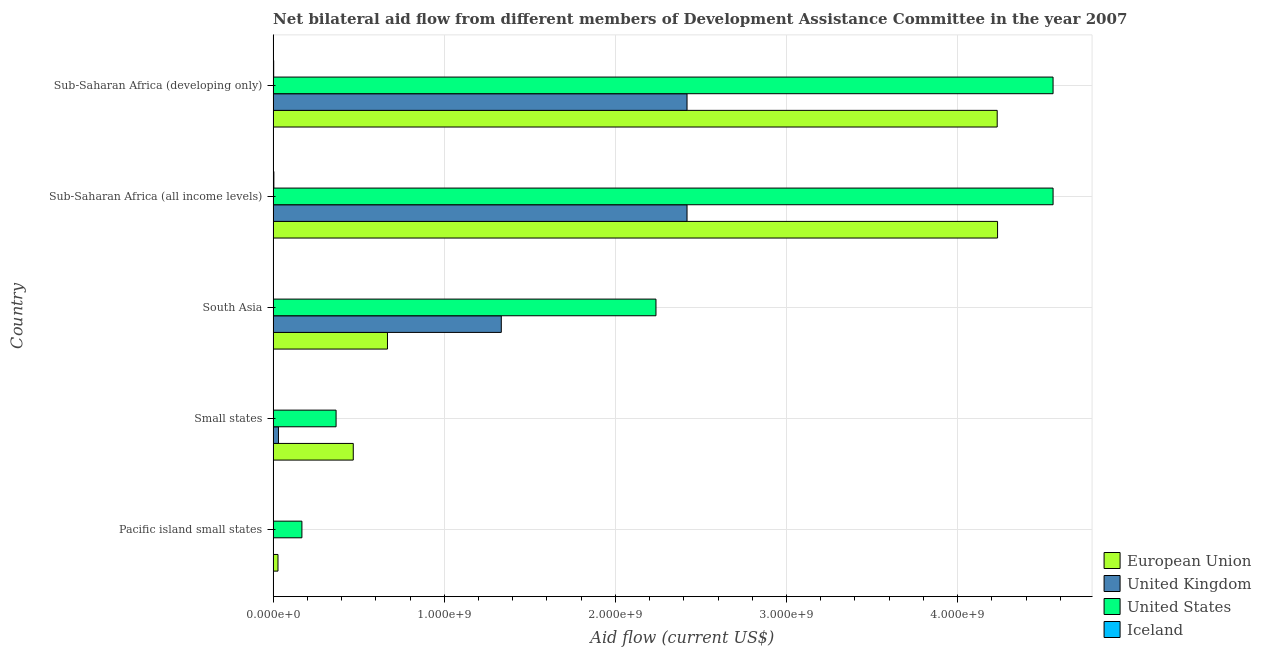How many different coloured bars are there?
Offer a very short reply. 4. How many groups of bars are there?
Make the answer very short. 5. Are the number of bars on each tick of the Y-axis equal?
Your answer should be compact. Yes. How many bars are there on the 2nd tick from the top?
Make the answer very short. 4. What is the label of the 5th group of bars from the top?
Make the answer very short. Pacific island small states. What is the amount of aid given by eu in Sub-Saharan Africa (developing only)?
Provide a short and direct response. 4.23e+09. Across all countries, what is the maximum amount of aid given by us?
Provide a short and direct response. 4.56e+09. Across all countries, what is the minimum amount of aid given by eu?
Offer a terse response. 2.84e+07. In which country was the amount of aid given by us maximum?
Offer a very short reply. Sub-Saharan Africa (all income levels). In which country was the amount of aid given by eu minimum?
Ensure brevity in your answer.  Pacific island small states. What is the total amount of aid given by us in the graph?
Provide a short and direct response. 1.19e+1. What is the difference between the amount of aid given by eu in Sub-Saharan Africa (all income levels) and that in Sub-Saharan Africa (developing only)?
Give a very brief answer. 2.07e+06. What is the difference between the amount of aid given by eu in Small states and the amount of aid given by uk in Sub-Saharan Africa (developing only)?
Make the answer very short. -1.95e+09. What is the average amount of aid given by us per country?
Give a very brief answer. 2.38e+09. What is the difference between the amount of aid given by us and amount of aid given by eu in South Asia?
Offer a terse response. 1.57e+09. In how many countries, is the amount of aid given by uk greater than 3600000000 US$?
Provide a succinct answer. 0. What is the ratio of the amount of aid given by uk in Small states to that in South Asia?
Your answer should be very brief. 0.02. Is the amount of aid given by us in Pacific island small states less than that in Sub-Saharan Africa (all income levels)?
Ensure brevity in your answer.  Yes. What is the difference between the highest and the second highest amount of aid given by eu?
Your response must be concise. 2.07e+06. What is the difference between the highest and the lowest amount of aid given by eu?
Ensure brevity in your answer.  4.20e+09. In how many countries, is the amount of aid given by iceland greater than the average amount of aid given by iceland taken over all countries?
Offer a very short reply. 2. Is the sum of the amount of aid given by eu in South Asia and Sub-Saharan Africa (all income levels) greater than the maximum amount of aid given by uk across all countries?
Provide a succinct answer. Yes. Is it the case that in every country, the sum of the amount of aid given by eu and amount of aid given by us is greater than the sum of amount of aid given by uk and amount of aid given by iceland?
Provide a succinct answer. Yes. What does the 3rd bar from the bottom in Pacific island small states represents?
Your answer should be compact. United States. What is the difference between two consecutive major ticks on the X-axis?
Your answer should be very brief. 1.00e+09. Are the values on the major ticks of X-axis written in scientific E-notation?
Give a very brief answer. Yes. Does the graph contain any zero values?
Offer a terse response. No. Where does the legend appear in the graph?
Provide a succinct answer. Bottom right. How many legend labels are there?
Keep it short and to the point. 4. What is the title of the graph?
Offer a very short reply. Net bilateral aid flow from different members of Development Assistance Committee in the year 2007. What is the label or title of the Y-axis?
Your response must be concise. Country. What is the Aid flow (current US$) in European Union in Pacific island small states?
Ensure brevity in your answer.  2.84e+07. What is the Aid flow (current US$) of United Kingdom in Pacific island small states?
Provide a succinct answer. 1.02e+06. What is the Aid flow (current US$) of United States in Pacific island small states?
Ensure brevity in your answer.  1.68e+08. What is the Aid flow (current US$) in Iceland in Pacific island small states?
Your response must be concise. 2.90e+05. What is the Aid flow (current US$) of European Union in Small states?
Your response must be concise. 4.68e+08. What is the Aid flow (current US$) in United Kingdom in Small states?
Ensure brevity in your answer.  3.12e+07. What is the Aid flow (current US$) in United States in Small states?
Provide a succinct answer. 3.68e+08. What is the Aid flow (current US$) in Iceland in Small states?
Offer a terse response. 1.00e+05. What is the Aid flow (current US$) in European Union in South Asia?
Provide a short and direct response. 6.68e+08. What is the Aid flow (current US$) of United Kingdom in South Asia?
Your answer should be very brief. 1.33e+09. What is the Aid flow (current US$) in United States in South Asia?
Keep it short and to the point. 2.24e+09. What is the Aid flow (current US$) of European Union in Sub-Saharan Africa (all income levels)?
Your answer should be very brief. 4.23e+09. What is the Aid flow (current US$) in United Kingdom in Sub-Saharan Africa (all income levels)?
Make the answer very short. 2.42e+09. What is the Aid flow (current US$) in United States in Sub-Saharan Africa (all income levels)?
Your answer should be compact. 4.56e+09. What is the Aid flow (current US$) of Iceland in Sub-Saharan Africa (all income levels)?
Ensure brevity in your answer.  4.37e+06. What is the Aid flow (current US$) of European Union in Sub-Saharan Africa (developing only)?
Your response must be concise. 4.23e+09. What is the Aid flow (current US$) of United Kingdom in Sub-Saharan Africa (developing only)?
Ensure brevity in your answer.  2.42e+09. What is the Aid flow (current US$) in United States in Sub-Saharan Africa (developing only)?
Provide a succinct answer. 4.56e+09. What is the Aid flow (current US$) in Iceland in Sub-Saharan Africa (developing only)?
Make the answer very short. 3.33e+06. Across all countries, what is the maximum Aid flow (current US$) in European Union?
Give a very brief answer. 4.23e+09. Across all countries, what is the maximum Aid flow (current US$) in United Kingdom?
Give a very brief answer. 2.42e+09. Across all countries, what is the maximum Aid flow (current US$) in United States?
Your answer should be compact. 4.56e+09. Across all countries, what is the maximum Aid flow (current US$) of Iceland?
Your answer should be compact. 4.37e+06. Across all countries, what is the minimum Aid flow (current US$) in European Union?
Offer a terse response. 2.84e+07. Across all countries, what is the minimum Aid flow (current US$) in United Kingdom?
Offer a terse response. 1.02e+06. Across all countries, what is the minimum Aid flow (current US$) of United States?
Your answer should be compact. 1.68e+08. What is the total Aid flow (current US$) of European Union in the graph?
Ensure brevity in your answer.  9.63e+09. What is the total Aid flow (current US$) of United Kingdom in the graph?
Your response must be concise. 6.20e+09. What is the total Aid flow (current US$) of United States in the graph?
Your answer should be compact. 1.19e+1. What is the total Aid flow (current US$) in Iceland in the graph?
Keep it short and to the point. 8.31e+06. What is the difference between the Aid flow (current US$) in European Union in Pacific island small states and that in Small states?
Ensure brevity in your answer.  -4.40e+08. What is the difference between the Aid flow (current US$) of United Kingdom in Pacific island small states and that in Small states?
Your response must be concise. -3.02e+07. What is the difference between the Aid flow (current US$) of United States in Pacific island small states and that in Small states?
Offer a very short reply. -2.00e+08. What is the difference between the Aid flow (current US$) of European Union in Pacific island small states and that in South Asia?
Offer a terse response. -6.40e+08. What is the difference between the Aid flow (current US$) in United Kingdom in Pacific island small states and that in South Asia?
Your answer should be very brief. -1.33e+09. What is the difference between the Aid flow (current US$) of United States in Pacific island small states and that in South Asia?
Ensure brevity in your answer.  -2.07e+09. What is the difference between the Aid flow (current US$) of European Union in Pacific island small states and that in Sub-Saharan Africa (all income levels)?
Offer a terse response. -4.20e+09. What is the difference between the Aid flow (current US$) in United Kingdom in Pacific island small states and that in Sub-Saharan Africa (all income levels)?
Make the answer very short. -2.42e+09. What is the difference between the Aid flow (current US$) of United States in Pacific island small states and that in Sub-Saharan Africa (all income levels)?
Ensure brevity in your answer.  -4.39e+09. What is the difference between the Aid flow (current US$) in Iceland in Pacific island small states and that in Sub-Saharan Africa (all income levels)?
Keep it short and to the point. -4.08e+06. What is the difference between the Aid flow (current US$) of European Union in Pacific island small states and that in Sub-Saharan Africa (developing only)?
Your answer should be very brief. -4.20e+09. What is the difference between the Aid flow (current US$) of United Kingdom in Pacific island small states and that in Sub-Saharan Africa (developing only)?
Offer a very short reply. -2.42e+09. What is the difference between the Aid flow (current US$) of United States in Pacific island small states and that in Sub-Saharan Africa (developing only)?
Ensure brevity in your answer.  -4.39e+09. What is the difference between the Aid flow (current US$) in Iceland in Pacific island small states and that in Sub-Saharan Africa (developing only)?
Your answer should be very brief. -3.04e+06. What is the difference between the Aid flow (current US$) of European Union in Small states and that in South Asia?
Offer a terse response. -2.00e+08. What is the difference between the Aid flow (current US$) in United Kingdom in Small states and that in South Asia?
Your answer should be very brief. -1.30e+09. What is the difference between the Aid flow (current US$) of United States in Small states and that in South Asia?
Offer a terse response. -1.87e+09. What is the difference between the Aid flow (current US$) of Iceland in Small states and that in South Asia?
Offer a terse response. -1.20e+05. What is the difference between the Aid flow (current US$) of European Union in Small states and that in Sub-Saharan Africa (all income levels)?
Your response must be concise. -3.76e+09. What is the difference between the Aid flow (current US$) in United Kingdom in Small states and that in Sub-Saharan Africa (all income levels)?
Keep it short and to the point. -2.39e+09. What is the difference between the Aid flow (current US$) of United States in Small states and that in Sub-Saharan Africa (all income levels)?
Provide a short and direct response. -4.19e+09. What is the difference between the Aid flow (current US$) in Iceland in Small states and that in Sub-Saharan Africa (all income levels)?
Offer a very short reply. -4.27e+06. What is the difference between the Aid flow (current US$) in European Union in Small states and that in Sub-Saharan Africa (developing only)?
Your answer should be very brief. -3.76e+09. What is the difference between the Aid flow (current US$) of United Kingdom in Small states and that in Sub-Saharan Africa (developing only)?
Offer a very short reply. -2.39e+09. What is the difference between the Aid flow (current US$) in United States in Small states and that in Sub-Saharan Africa (developing only)?
Keep it short and to the point. -4.19e+09. What is the difference between the Aid flow (current US$) of Iceland in Small states and that in Sub-Saharan Africa (developing only)?
Provide a short and direct response. -3.23e+06. What is the difference between the Aid flow (current US$) in European Union in South Asia and that in Sub-Saharan Africa (all income levels)?
Give a very brief answer. -3.57e+09. What is the difference between the Aid flow (current US$) in United Kingdom in South Asia and that in Sub-Saharan Africa (all income levels)?
Provide a succinct answer. -1.09e+09. What is the difference between the Aid flow (current US$) of United States in South Asia and that in Sub-Saharan Africa (all income levels)?
Make the answer very short. -2.32e+09. What is the difference between the Aid flow (current US$) in Iceland in South Asia and that in Sub-Saharan Africa (all income levels)?
Keep it short and to the point. -4.15e+06. What is the difference between the Aid flow (current US$) of European Union in South Asia and that in Sub-Saharan Africa (developing only)?
Give a very brief answer. -3.56e+09. What is the difference between the Aid flow (current US$) of United Kingdom in South Asia and that in Sub-Saharan Africa (developing only)?
Provide a short and direct response. -1.09e+09. What is the difference between the Aid flow (current US$) of United States in South Asia and that in Sub-Saharan Africa (developing only)?
Your response must be concise. -2.32e+09. What is the difference between the Aid flow (current US$) in Iceland in South Asia and that in Sub-Saharan Africa (developing only)?
Provide a succinct answer. -3.11e+06. What is the difference between the Aid flow (current US$) in European Union in Sub-Saharan Africa (all income levels) and that in Sub-Saharan Africa (developing only)?
Provide a succinct answer. 2.07e+06. What is the difference between the Aid flow (current US$) in Iceland in Sub-Saharan Africa (all income levels) and that in Sub-Saharan Africa (developing only)?
Provide a short and direct response. 1.04e+06. What is the difference between the Aid flow (current US$) in European Union in Pacific island small states and the Aid flow (current US$) in United Kingdom in Small states?
Offer a very short reply. -2.85e+06. What is the difference between the Aid flow (current US$) of European Union in Pacific island small states and the Aid flow (current US$) of United States in Small states?
Ensure brevity in your answer.  -3.40e+08. What is the difference between the Aid flow (current US$) in European Union in Pacific island small states and the Aid flow (current US$) in Iceland in Small states?
Your response must be concise. 2.83e+07. What is the difference between the Aid flow (current US$) of United Kingdom in Pacific island small states and the Aid flow (current US$) of United States in Small states?
Provide a succinct answer. -3.67e+08. What is the difference between the Aid flow (current US$) of United Kingdom in Pacific island small states and the Aid flow (current US$) of Iceland in Small states?
Your answer should be very brief. 9.20e+05. What is the difference between the Aid flow (current US$) of United States in Pacific island small states and the Aid flow (current US$) of Iceland in Small states?
Give a very brief answer. 1.68e+08. What is the difference between the Aid flow (current US$) of European Union in Pacific island small states and the Aid flow (current US$) of United Kingdom in South Asia?
Provide a short and direct response. -1.30e+09. What is the difference between the Aid flow (current US$) in European Union in Pacific island small states and the Aid flow (current US$) in United States in South Asia?
Give a very brief answer. -2.21e+09. What is the difference between the Aid flow (current US$) of European Union in Pacific island small states and the Aid flow (current US$) of Iceland in South Asia?
Your response must be concise. 2.82e+07. What is the difference between the Aid flow (current US$) in United Kingdom in Pacific island small states and the Aid flow (current US$) in United States in South Asia?
Offer a terse response. -2.24e+09. What is the difference between the Aid flow (current US$) of United Kingdom in Pacific island small states and the Aid flow (current US$) of Iceland in South Asia?
Keep it short and to the point. 8.00e+05. What is the difference between the Aid flow (current US$) of United States in Pacific island small states and the Aid flow (current US$) of Iceland in South Asia?
Your response must be concise. 1.68e+08. What is the difference between the Aid flow (current US$) in European Union in Pacific island small states and the Aid flow (current US$) in United Kingdom in Sub-Saharan Africa (all income levels)?
Keep it short and to the point. -2.39e+09. What is the difference between the Aid flow (current US$) of European Union in Pacific island small states and the Aid flow (current US$) of United States in Sub-Saharan Africa (all income levels)?
Provide a short and direct response. -4.53e+09. What is the difference between the Aid flow (current US$) in European Union in Pacific island small states and the Aid flow (current US$) in Iceland in Sub-Saharan Africa (all income levels)?
Ensure brevity in your answer.  2.40e+07. What is the difference between the Aid flow (current US$) of United Kingdom in Pacific island small states and the Aid flow (current US$) of United States in Sub-Saharan Africa (all income levels)?
Offer a terse response. -4.56e+09. What is the difference between the Aid flow (current US$) of United Kingdom in Pacific island small states and the Aid flow (current US$) of Iceland in Sub-Saharan Africa (all income levels)?
Give a very brief answer. -3.35e+06. What is the difference between the Aid flow (current US$) of United States in Pacific island small states and the Aid flow (current US$) of Iceland in Sub-Saharan Africa (all income levels)?
Keep it short and to the point. 1.64e+08. What is the difference between the Aid flow (current US$) of European Union in Pacific island small states and the Aid flow (current US$) of United Kingdom in Sub-Saharan Africa (developing only)?
Offer a terse response. -2.39e+09. What is the difference between the Aid flow (current US$) of European Union in Pacific island small states and the Aid flow (current US$) of United States in Sub-Saharan Africa (developing only)?
Make the answer very short. -4.53e+09. What is the difference between the Aid flow (current US$) in European Union in Pacific island small states and the Aid flow (current US$) in Iceland in Sub-Saharan Africa (developing only)?
Your answer should be very brief. 2.51e+07. What is the difference between the Aid flow (current US$) of United Kingdom in Pacific island small states and the Aid flow (current US$) of United States in Sub-Saharan Africa (developing only)?
Make the answer very short. -4.56e+09. What is the difference between the Aid flow (current US$) of United Kingdom in Pacific island small states and the Aid flow (current US$) of Iceland in Sub-Saharan Africa (developing only)?
Give a very brief answer. -2.31e+06. What is the difference between the Aid flow (current US$) in United States in Pacific island small states and the Aid flow (current US$) in Iceland in Sub-Saharan Africa (developing only)?
Your response must be concise. 1.65e+08. What is the difference between the Aid flow (current US$) of European Union in Small states and the Aid flow (current US$) of United Kingdom in South Asia?
Provide a short and direct response. -8.65e+08. What is the difference between the Aid flow (current US$) in European Union in Small states and the Aid flow (current US$) in United States in South Asia?
Make the answer very short. -1.77e+09. What is the difference between the Aid flow (current US$) of European Union in Small states and the Aid flow (current US$) of Iceland in South Asia?
Your response must be concise. 4.68e+08. What is the difference between the Aid flow (current US$) of United Kingdom in Small states and the Aid flow (current US$) of United States in South Asia?
Ensure brevity in your answer.  -2.21e+09. What is the difference between the Aid flow (current US$) in United Kingdom in Small states and the Aid flow (current US$) in Iceland in South Asia?
Make the answer very short. 3.10e+07. What is the difference between the Aid flow (current US$) of United States in Small states and the Aid flow (current US$) of Iceland in South Asia?
Your response must be concise. 3.68e+08. What is the difference between the Aid flow (current US$) in European Union in Small states and the Aid flow (current US$) in United Kingdom in Sub-Saharan Africa (all income levels)?
Make the answer very short. -1.95e+09. What is the difference between the Aid flow (current US$) of European Union in Small states and the Aid flow (current US$) of United States in Sub-Saharan Africa (all income levels)?
Your answer should be compact. -4.09e+09. What is the difference between the Aid flow (current US$) of European Union in Small states and the Aid flow (current US$) of Iceland in Sub-Saharan Africa (all income levels)?
Provide a short and direct response. 4.64e+08. What is the difference between the Aid flow (current US$) in United Kingdom in Small states and the Aid flow (current US$) in United States in Sub-Saharan Africa (all income levels)?
Offer a very short reply. -4.53e+09. What is the difference between the Aid flow (current US$) in United Kingdom in Small states and the Aid flow (current US$) in Iceland in Sub-Saharan Africa (all income levels)?
Ensure brevity in your answer.  2.69e+07. What is the difference between the Aid flow (current US$) in United States in Small states and the Aid flow (current US$) in Iceland in Sub-Saharan Africa (all income levels)?
Your response must be concise. 3.64e+08. What is the difference between the Aid flow (current US$) in European Union in Small states and the Aid flow (current US$) in United Kingdom in Sub-Saharan Africa (developing only)?
Your answer should be very brief. -1.95e+09. What is the difference between the Aid flow (current US$) of European Union in Small states and the Aid flow (current US$) of United States in Sub-Saharan Africa (developing only)?
Offer a very short reply. -4.09e+09. What is the difference between the Aid flow (current US$) of European Union in Small states and the Aid flow (current US$) of Iceland in Sub-Saharan Africa (developing only)?
Offer a terse response. 4.65e+08. What is the difference between the Aid flow (current US$) in United Kingdom in Small states and the Aid flow (current US$) in United States in Sub-Saharan Africa (developing only)?
Offer a terse response. -4.53e+09. What is the difference between the Aid flow (current US$) in United Kingdom in Small states and the Aid flow (current US$) in Iceland in Sub-Saharan Africa (developing only)?
Provide a short and direct response. 2.79e+07. What is the difference between the Aid flow (current US$) of United States in Small states and the Aid flow (current US$) of Iceland in Sub-Saharan Africa (developing only)?
Give a very brief answer. 3.65e+08. What is the difference between the Aid flow (current US$) in European Union in South Asia and the Aid flow (current US$) in United Kingdom in Sub-Saharan Africa (all income levels)?
Your response must be concise. -1.75e+09. What is the difference between the Aid flow (current US$) in European Union in South Asia and the Aid flow (current US$) in United States in Sub-Saharan Africa (all income levels)?
Keep it short and to the point. -3.89e+09. What is the difference between the Aid flow (current US$) in European Union in South Asia and the Aid flow (current US$) in Iceland in Sub-Saharan Africa (all income levels)?
Your answer should be very brief. 6.64e+08. What is the difference between the Aid flow (current US$) of United Kingdom in South Asia and the Aid flow (current US$) of United States in Sub-Saharan Africa (all income levels)?
Give a very brief answer. -3.22e+09. What is the difference between the Aid flow (current US$) in United Kingdom in South Asia and the Aid flow (current US$) in Iceland in Sub-Saharan Africa (all income levels)?
Provide a succinct answer. 1.33e+09. What is the difference between the Aid flow (current US$) of United States in South Asia and the Aid flow (current US$) of Iceland in Sub-Saharan Africa (all income levels)?
Keep it short and to the point. 2.23e+09. What is the difference between the Aid flow (current US$) in European Union in South Asia and the Aid flow (current US$) in United Kingdom in Sub-Saharan Africa (developing only)?
Make the answer very short. -1.75e+09. What is the difference between the Aid flow (current US$) of European Union in South Asia and the Aid flow (current US$) of United States in Sub-Saharan Africa (developing only)?
Make the answer very short. -3.89e+09. What is the difference between the Aid flow (current US$) of European Union in South Asia and the Aid flow (current US$) of Iceland in Sub-Saharan Africa (developing only)?
Provide a succinct answer. 6.65e+08. What is the difference between the Aid flow (current US$) in United Kingdom in South Asia and the Aid flow (current US$) in United States in Sub-Saharan Africa (developing only)?
Offer a terse response. -3.22e+09. What is the difference between the Aid flow (current US$) of United Kingdom in South Asia and the Aid flow (current US$) of Iceland in Sub-Saharan Africa (developing only)?
Your answer should be very brief. 1.33e+09. What is the difference between the Aid flow (current US$) of United States in South Asia and the Aid flow (current US$) of Iceland in Sub-Saharan Africa (developing only)?
Give a very brief answer. 2.23e+09. What is the difference between the Aid flow (current US$) of European Union in Sub-Saharan Africa (all income levels) and the Aid flow (current US$) of United Kingdom in Sub-Saharan Africa (developing only)?
Ensure brevity in your answer.  1.81e+09. What is the difference between the Aid flow (current US$) in European Union in Sub-Saharan Africa (all income levels) and the Aid flow (current US$) in United States in Sub-Saharan Africa (developing only)?
Keep it short and to the point. -3.24e+08. What is the difference between the Aid flow (current US$) in European Union in Sub-Saharan Africa (all income levels) and the Aid flow (current US$) in Iceland in Sub-Saharan Africa (developing only)?
Offer a terse response. 4.23e+09. What is the difference between the Aid flow (current US$) in United Kingdom in Sub-Saharan Africa (all income levels) and the Aid flow (current US$) in United States in Sub-Saharan Africa (developing only)?
Provide a succinct answer. -2.14e+09. What is the difference between the Aid flow (current US$) in United Kingdom in Sub-Saharan Africa (all income levels) and the Aid flow (current US$) in Iceland in Sub-Saharan Africa (developing only)?
Provide a succinct answer. 2.42e+09. What is the difference between the Aid flow (current US$) of United States in Sub-Saharan Africa (all income levels) and the Aid flow (current US$) of Iceland in Sub-Saharan Africa (developing only)?
Provide a short and direct response. 4.55e+09. What is the average Aid flow (current US$) in European Union per country?
Offer a terse response. 1.93e+09. What is the average Aid flow (current US$) in United Kingdom per country?
Give a very brief answer. 1.24e+09. What is the average Aid flow (current US$) in United States per country?
Provide a succinct answer. 2.38e+09. What is the average Aid flow (current US$) in Iceland per country?
Keep it short and to the point. 1.66e+06. What is the difference between the Aid flow (current US$) of European Union and Aid flow (current US$) of United Kingdom in Pacific island small states?
Provide a succinct answer. 2.74e+07. What is the difference between the Aid flow (current US$) in European Union and Aid flow (current US$) in United States in Pacific island small states?
Provide a short and direct response. -1.40e+08. What is the difference between the Aid flow (current US$) in European Union and Aid flow (current US$) in Iceland in Pacific island small states?
Keep it short and to the point. 2.81e+07. What is the difference between the Aid flow (current US$) of United Kingdom and Aid flow (current US$) of United States in Pacific island small states?
Offer a terse response. -1.67e+08. What is the difference between the Aid flow (current US$) of United Kingdom and Aid flow (current US$) of Iceland in Pacific island small states?
Give a very brief answer. 7.30e+05. What is the difference between the Aid flow (current US$) in United States and Aid flow (current US$) in Iceland in Pacific island small states?
Your answer should be very brief. 1.68e+08. What is the difference between the Aid flow (current US$) in European Union and Aid flow (current US$) in United Kingdom in Small states?
Ensure brevity in your answer.  4.37e+08. What is the difference between the Aid flow (current US$) of European Union and Aid flow (current US$) of United States in Small states?
Offer a terse response. 1.00e+08. What is the difference between the Aid flow (current US$) in European Union and Aid flow (current US$) in Iceland in Small states?
Your answer should be compact. 4.68e+08. What is the difference between the Aid flow (current US$) of United Kingdom and Aid flow (current US$) of United States in Small states?
Offer a very short reply. -3.37e+08. What is the difference between the Aid flow (current US$) of United Kingdom and Aid flow (current US$) of Iceland in Small states?
Give a very brief answer. 3.12e+07. What is the difference between the Aid flow (current US$) of United States and Aid flow (current US$) of Iceland in Small states?
Offer a very short reply. 3.68e+08. What is the difference between the Aid flow (current US$) of European Union and Aid flow (current US$) of United Kingdom in South Asia?
Offer a very short reply. -6.65e+08. What is the difference between the Aid flow (current US$) of European Union and Aid flow (current US$) of United States in South Asia?
Ensure brevity in your answer.  -1.57e+09. What is the difference between the Aid flow (current US$) in European Union and Aid flow (current US$) in Iceland in South Asia?
Provide a succinct answer. 6.68e+08. What is the difference between the Aid flow (current US$) of United Kingdom and Aid flow (current US$) of United States in South Asia?
Keep it short and to the point. -9.04e+08. What is the difference between the Aid flow (current US$) of United Kingdom and Aid flow (current US$) of Iceland in South Asia?
Provide a short and direct response. 1.33e+09. What is the difference between the Aid flow (current US$) of United States and Aid flow (current US$) of Iceland in South Asia?
Your response must be concise. 2.24e+09. What is the difference between the Aid flow (current US$) of European Union and Aid flow (current US$) of United Kingdom in Sub-Saharan Africa (all income levels)?
Make the answer very short. 1.81e+09. What is the difference between the Aid flow (current US$) of European Union and Aid flow (current US$) of United States in Sub-Saharan Africa (all income levels)?
Provide a short and direct response. -3.24e+08. What is the difference between the Aid flow (current US$) of European Union and Aid flow (current US$) of Iceland in Sub-Saharan Africa (all income levels)?
Your answer should be very brief. 4.23e+09. What is the difference between the Aid flow (current US$) in United Kingdom and Aid flow (current US$) in United States in Sub-Saharan Africa (all income levels)?
Ensure brevity in your answer.  -2.14e+09. What is the difference between the Aid flow (current US$) of United Kingdom and Aid flow (current US$) of Iceland in Sub-Saharan Africa (all income levels)?
Provide a short and direct response. 2.41e+09. What is the difference between the Aid flow (current US$) in United States and Aid flow (current US$) in Iceland in Sub-Saharan Africa (all income levels)?
Offer a terse response. 4.55e+09. What is the difference between the Aid flow (current US$) of European Union and Aid flow (current US$) of United Kingdom in Sub-Saharan Africa (developing only)?
Make the answer very short. 1.81e+09. What is the difference between the Aid flow (current US$) in European Union and Aid flow (current US$) in United States in Sub-Saharan Africa (developing only)?
Ensure brevity in your answer.  -3.26e+08. What is the difference between the Aid flow (current US$) of European Union and Aid flow (current US$) of Iceland in Sub-Saharan Africa (developing only)?
Ensure brevity in your answer.  4.23e+09. What is the difference between the Aid flow (current US$) of United Kingdom and Aid flow (current US$) of United States in Sub-Saharan Africa (developing only)?
Your response must be concise. -2.14e+09. What is the difference between the Aid flow (current US$) of United Kingdom and Aid flow (current US$) of Iceland in Sub-Saharan Africa (developing only)?
Keep it short and to the point. 2.42e+09. What is the difference between the Aid flow (current US$) in United States and Aid flow (current US$) in Iceland in Sub-Saharan Africa (developing only)?
Keep it short and to the point. 4.55e+09. What is the ratio of the Aid flow (current US$) of European Union in Pacific island small states to that in Small states?
Give a very brief answer. 0.06. What is the ratio of the Aid flow (current US$) of United Kingdom in Pacific island small states to that in Small states?
Ensure brevity in your answer.  0.03. What is the ratio of the Aid flow (current US$) of United States in Pacific island small states to that in Small states?
Your answer should be compact. 0.46. What is the ratio of the Aid flow (current US$) in European Union in Pacific island small states to that in South Asia?
Make the answer very short. 0.04. What is the ratio of the Aid flow (current US$) in United Kingdom in Pacific island small states to that in South Asia?
Your response must be concise. 0. What is the ratio of the Aid flow (current US$) in United States in Pacific island small states to that in South Asia?
Your response must be concise. 0.08. What is the ratio of the Aid flow (current US$) of Iceland in Pacific island small states to that in South Asia?
Provide a succinct answer. 1.32. What is the ratio of the Aid flow (current US$) of European Union in Pacific island small states to that in Sub-Saharan Africa (all income levels)?
Your answer should be compact. 0.01. What is the ratio of the Aid flow (current US$) of United States in Pacific island small states to that in Sub-Saharan Africa (all income levels)?
Make the answer very short. 0.04. What is the ratio of the Aid flow (current US$) of Iceland in Pacific island small states to that in Sub-Saharan Africa (all income levels)?
Ensure brevity in your answer.  0.07. What is the ratio of the Aid flow (current US$) in European Union in Pacific island small states to that in Sub-Saharan Africa (developing only)?
Your response must be concise. 0.01. What is the ratio of the Aid flow (current US$) of United Kingdom in Pacific island small states to that in Sub-Saharan Africa (developing only)?
Your response must be concise. 0. What is the ratio of the Aid flow (current US$) of United States in Pacific island small states to that in Sub-Saharan Africa (developing only)?
Give a very brief answer. 0.04. What is the ratio of the Aid flow (current US$) in Iceland in Pacific island small states to that in Sub-Saharan Africa (developing only)?
Offer a terse response. 0.09. What is the ratio of the Aid flow (current US$) of European Union in Small states to that in South Asia?
Your answer should be compact. 0.7. What is the ratio of the Aid flow (current US$) in United Kingdom in Small states to that in South Asia?
Provide a short and direct response. 0.02. What is the ratio of the Aid flow (current US$) in United States in Small states to that in South Asia?
Make the answer very short. 0.16. What is the ratio of the Aid flow (current US$) of Iceland in Small states to that in South Asia?
Provide a short and direct response. 0.45. What is the ratio of the Aid flow (current US$) in European Union in Small states to that in Sub-Saharan Africa (all income levels)?
Keep it short and to the point. 0.11. What is the ratio of the Aid flow (current US$) in United Kingdom in Small states to that in Sub-Saharan Africa (all income levels)?
Your answer should be very brief. 0.01. What is the ratio of the Aid flow (current US$) of United States in Small states to that in Sub-Saharan Africa (all income levels)?
Ensure brevity in your answer.  0.08. What is the ratio of the Aid flow (current US$) of Iceland in Small states to that in Sub-Saharan Africa (all income levels)?
Your answer should be compact. 0.02. What is the ratio of the Aid flow (current US$) in European Union in Small states to that in Sub-Saharan Africa (developing only)?
Your answer should be compact. 0.11. What is the ratio of the Aid flow (current US$) in United Kingdom in Small states to that in Sub-Saharan Africa (developing only)?
Provide a succinct answer. 0.01. What is the ratio of the Aid flow (current US$) of United States in Small states to that in Sub-Saharan Africa (developing only)?
Offer a very short reply. 0.08. What is the ratio of the Aid flow (current US$) of Iceland in Small states to that in Sub-Saharan Africa (developing only)?
Provide a short and direct response. 0.03. What is the ratio of the Aid flow (current US$) in European Union in South Asia to that in Sub-Saharan Africa (all income levels)?
Make the answer very short. 0.16. What is the ratio of the Aid flow (current US$) in United Kingdom in South Asia to that in Sub-Saharan Africa (all income levels)?
Make the answer very short. 0.55. What is the ratio of the Aid flow (current US$) in United States in South Asia to that in Sub-Saharan Africa (all income levels)?
Offer a terse response. 0.49. What is the ratio of the Aid flow (current US$) of Iceland in South Asia to that in Sub-Saharan Africa (all income levels)?
Your answer should be very brief. 0.05. What is the ratio of the Aid flow (current US$) in European Union in South Asia to that in Sub-Saharan Africa (developing only)?
Provide a succinct answer. 0.16. What is the ratio of the Aid flow (current US$) in United Kingdom in South Asia to that in Sub-Saharan Africa (developing only)?
Your response must be concise. 0.55. What is the ratio of the Aid flow (current US$) in United States in South Asia to that in Sub-Saharan Africa (developing only)?
Keep it short and to the point. 0.49. What is the ratio of the Aid flow (current US$) of Iceland in South Asia to that in Sub-Saharan Africa (developing only)?
Provide a short and direct response. 0.07. What is the ratio of the Aid flow (current US$) in European Union in Sub-Saharan Africa (all income levels) to that in Sub-Saharan Africa (developing only)?
Offer a terse response. 1. What is the ratio of the Aid flow (current US$) in United States in Sub-Saharan Africa (all income levels) to that in Sub-Saharan Africa (developing only)?
Your answer should be compact. 1. What is the ratio of the Aid flow (current US$) of Iceland in Sub-Saharan Africa (all income levels) to that in Sub-Saharan Africa (developing only)?
Provide a succinct answer. 1.31. What is the difference between the highest and the second highest Aid flow (current US$) in European Union?
Your answer should be very brief. 2.07e+06. What is the difference between the highest and the second highest Aid flow (current US$) of Iceland?
Provide a succinct answer. 1.04e+06. What is the difference between the highest and the lowest Aid flow (current US$) in European Union?
Keep it short and to the point. 4.20e+09. What is the difference between the highest and the lowest Aid flow (current US$) of United Kingdom?
Offer a terse response. 2.42e+09. What is the difference between the highest and the lowest Aid flow (current US$) of United States?
Ensure brevity in your answer.  4.39e+09. What is the difference between the highest and the lowest Aid flow (current US$) of Iceland?
Your answer should be very brief. 4.27e+06. 